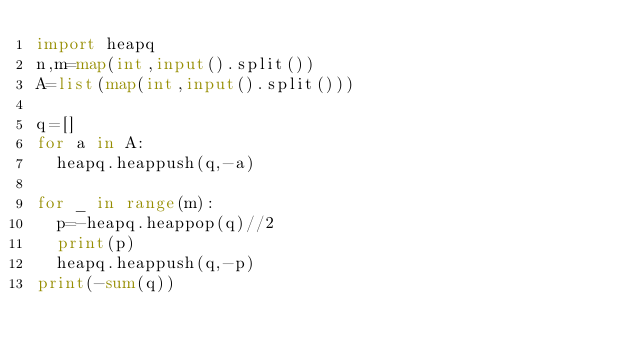Convert code to text. <code><loc_0><loc_0><loc_500><loc_500><_Python_>import heapq
n,m=map(int,input().split())
A=list(map(int,input().split()))

q=[]
for a in A:
  heapq.heappush(q,-a)
  
for _ in range(m):
  p=-heapq.heappop(q)//2
  print(p)
  heapq.heappush(q,-p)
print(-sum(q))
</code> 